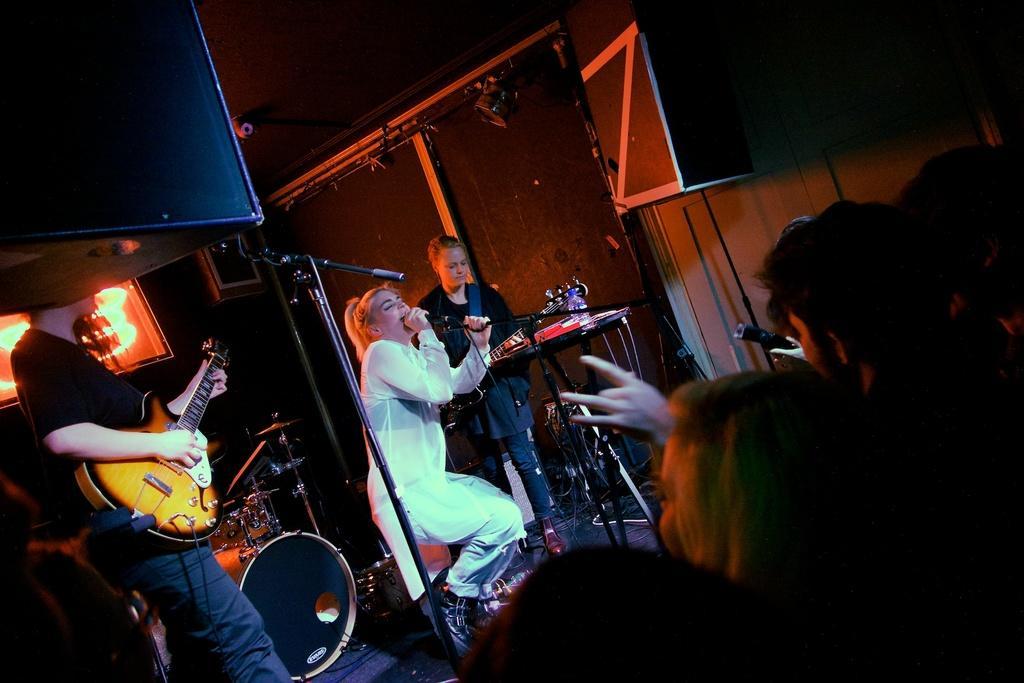How would you summarize this image in a sentence or two? One lady wearing white dress holding a mic and singing. Next to her a lady is holding a guitar. And left of her one guy is holding a guitar and playing. There are many musical instruments. And some people are standing over here and watching the show. 